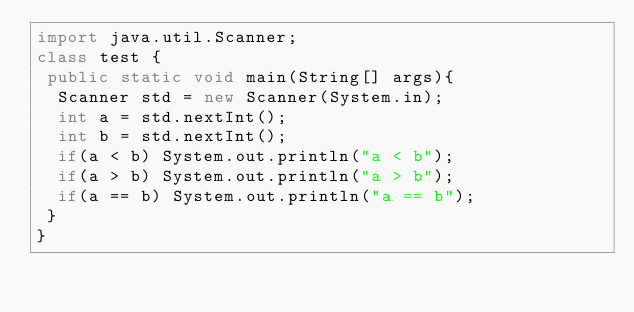Convert code to text. <code><loc_0><loc_0><loc_500><loc_500><_Java_>import java.util.Scanner;
class test {
 public static void main(String[] args){
  Scanner std = new Scanner(System.in);
  int a = std.nextInt();
  int b = std.nextInt();
  if(a < b) System.out.println("a < b");
  if(a > b) System.out.println("a > b");
  if(a == b) System.out.println("a == b");
 }
}</code> 